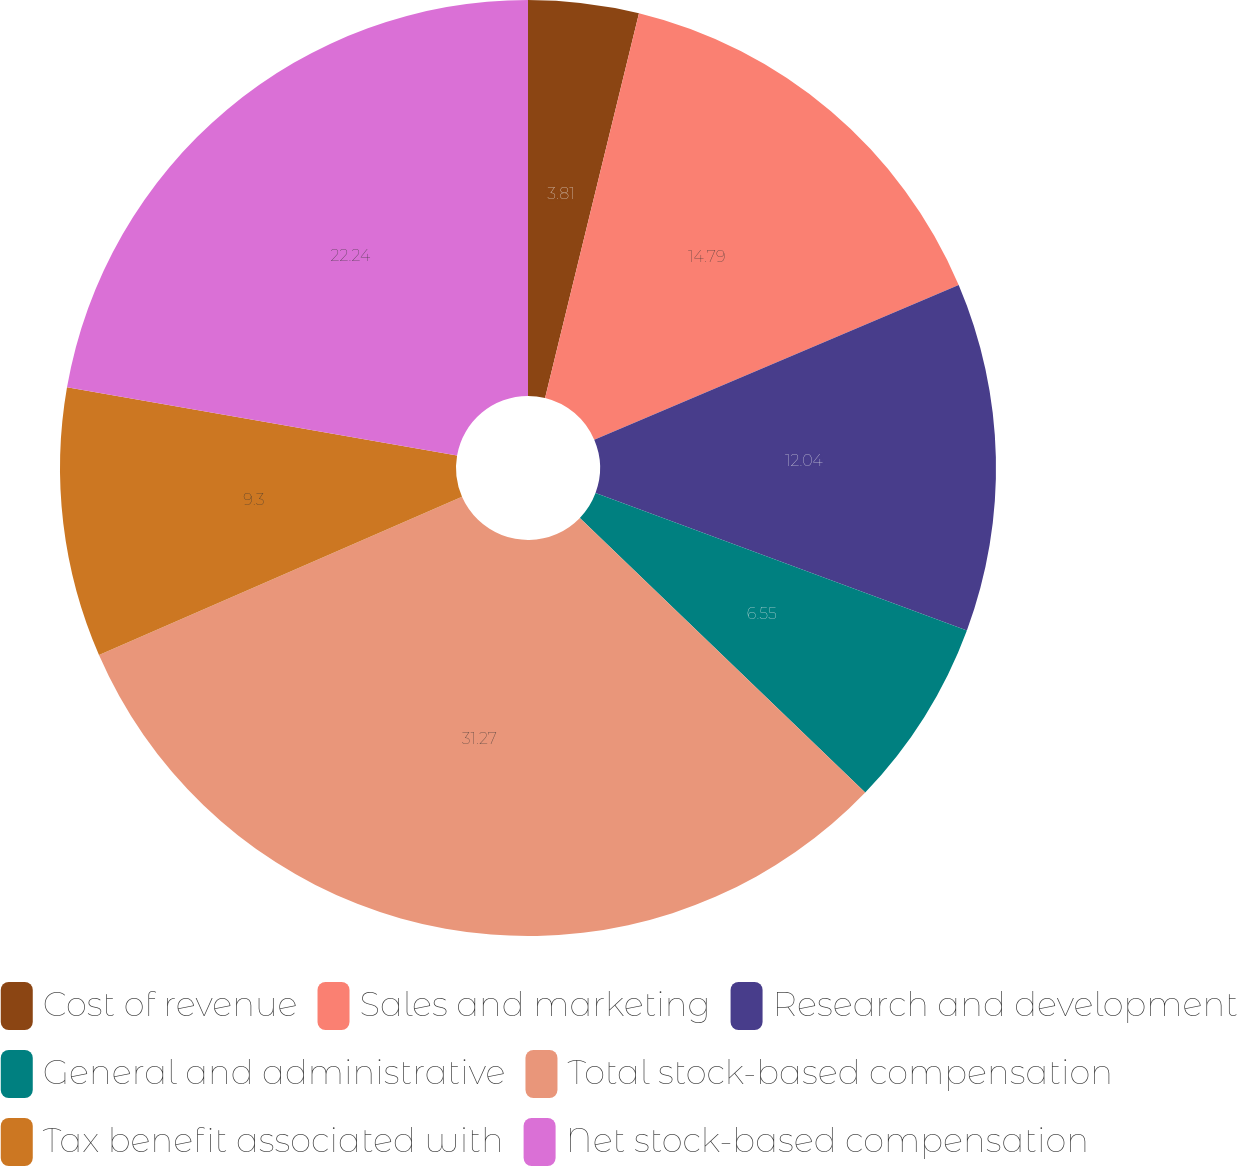<chart> <loc_0><loc_0><loc_500><loc_500><pie_chart><fcel>Cost of revenue<fcel>Sales and marketing<fcel>Research and development<fcel>General and administrative<fcel>Total stock-based compensation<fcel>Tax benefit associated with<fcel>Net stock-based compensation<nl><fcel>3.81%<fcel>14.79%<fcel>12.04%<fcel>6.55%<fcel>31.26%<fcel>9.3%<fcel>22.24%<nl></chart> 